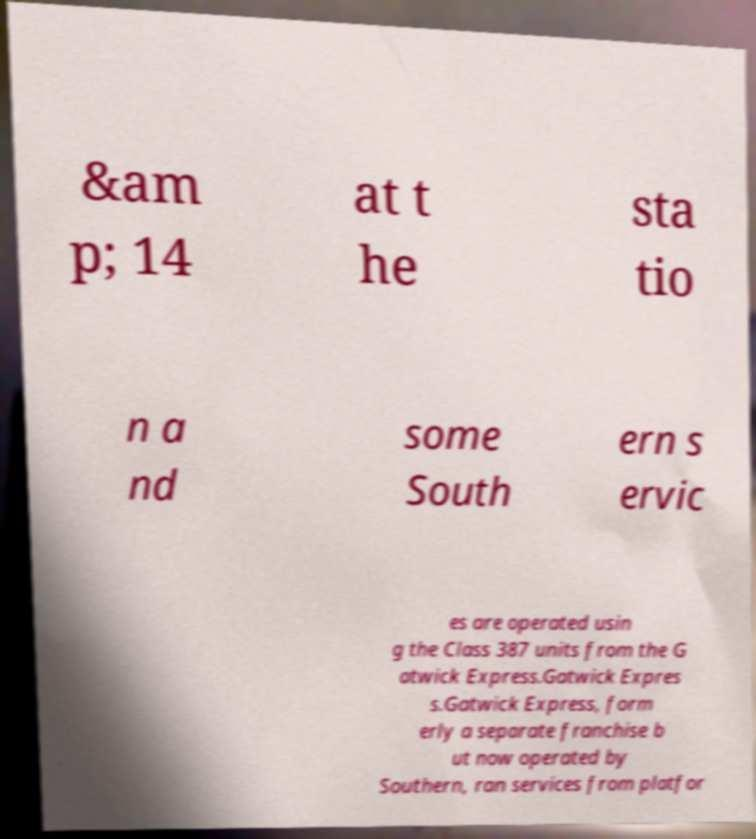What messages or text are displayed in this image? I need them in a readable, typed format. &am p; 14 at t he sta tio n a nd some South ern s ervic es are operated usin g the Class 387 units from the G atwick Express.Gatwick Expres s.Gatwick Express, form erly a separate franchise b ut now operated by Southern, ran services from platfor 